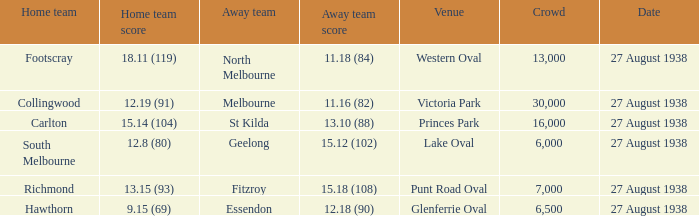Which home team had the away team score 15.18 (108) against them? 13.15 (93). 